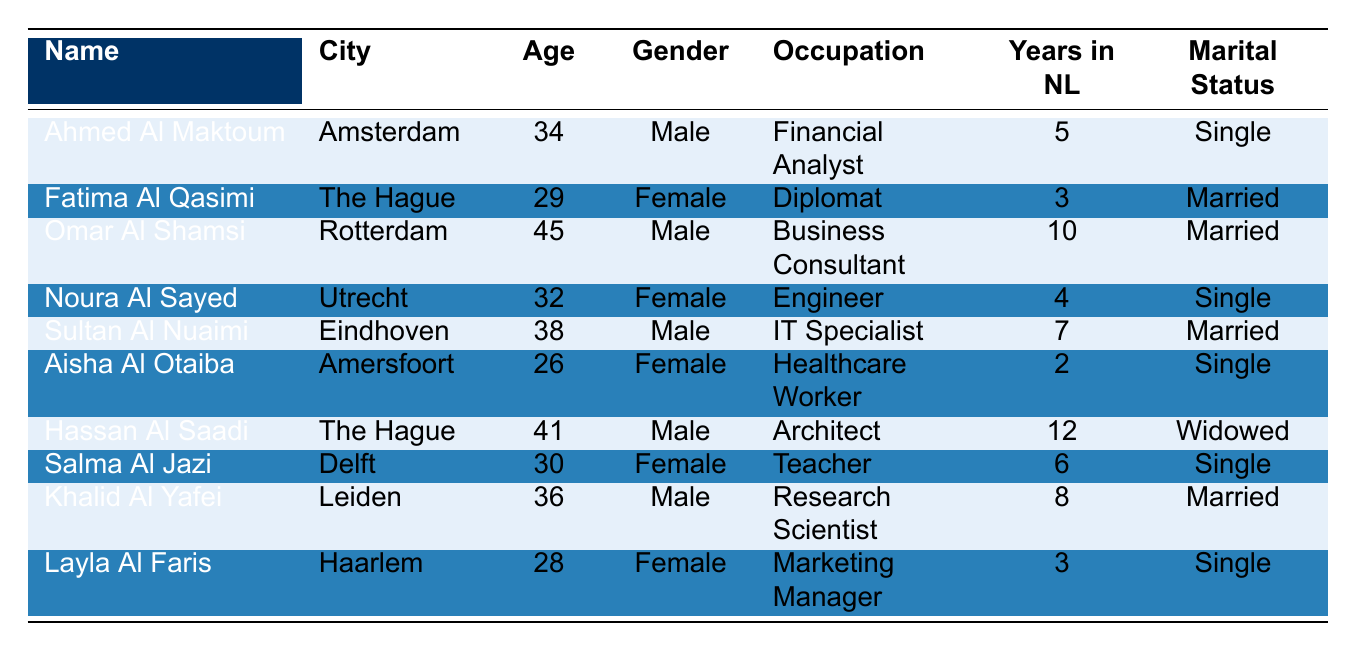What is the average age of the UAE nationals listed in the table? The ages listed are 34, 29, 45, 32, 38, 26, 41, 30, 36, and 28. There are 10 data points. The sum of their ages is 34 + 29 + 45 + 32 + 38 + 26 + 41 + 30 + 36 + 28 =  36. To find the average, divide by the number of individuals:  35/10 = 36.1; rounding to 36.
Answer: 36.1 How many UAE nationals are single? In the table, the individuals marked as single are Ahmed Al Maktoum, Noura Al Sayed, Aisha Al Otaiba, Salma Al Jazi, and Layla Al Faris. This results in a total of 5 singles.
Answer: 5 What is the most common city where UAE nationals reside according to the table? The cities listed are Amsterdam, The Hague, Rotterdam, Utrecht, Eindhoven, Amersfoort, Delft, Leiden, and Haarlem. The Hague appears twice (Fatima Al Qasimi and Hassan Al Saadi), while the others appear only once. Therefore, The Hague is the most common city.
Answer: The Hague Are there more male or female UAE nationals in the table? In the table, the genders are distributed as follows: 5 males (Ahmed Al Maktoum, Omar Al Shamsi, Sultan Al Nuaimi, Hassan Al Saadi, and Khalid Al Yafei) and 5 females (Fatima Al Qasimi, Noura Al Sayed, Aisha Al Otaiba, Salma Al Jazi, and Layla Al Faris). Since both numbers are equal, there is no majority gender.
Answer: Neither How many UAE nationals have lived in the Netherlands for more than 5 years? Omar Al Shamsi (10 years), Sultan Al Nuaimi (7 years), Hassan Al Saadi (12 years), and Khalid Al Yafei (8 years) have lived for more than 5 years. This gives a total of 4 individuals.
Answer: 4 What is the average number of years UAE nationals have lived in the Netherlands? The years listed are 5, 3, 10, 4, 7, 2, 12, 6, 8, and 3. The sum of these years is 5 + 3 + 10 + 4 + 7 + 2 + 12 + 6 + 8 + 3 = 60. To find the average, divide by the number of individuals: 60/10 = 6.
Answer: 6 Is there anyone listed as widowed? The table shows Hassan Al Saadi as the only individual with a marital status marked as 'Widowed.' Thus, there is a person who is widowed.
Answer: Yes Which occupation has the youngest UAE national? The youngest individual is Aisha Al Otaiba at 26 years old, who works as a Healthcare Worker. Thus, the occupation of the youngest individual is Healthcare Worker.
Answer: Healthcare Worker How many UAE nationals are married? The married individuals in the table are Fatima Al Qasimi, Omar Al Shamsi, Sultan Al Nuaimi, Khalid Al Yafei, resulting in a total of 4 married individuals.
Answer: 4 What is the gender distribution of the UAE nationals in the table? The table includes 5 males (Ahmed Al Maktoum, Omar Al Shamsi, Sultan Al Nuaimi, Hassan Al Saadi, Khalid Al Yafei) and 5 females (Fatima Al Qasimi, Noura Al Sayed, Aisha Al Otaiba, Salma Al Jazi, and Layla Al Faris). Therefore, the gender distribution is equal.
Answer: Equal 